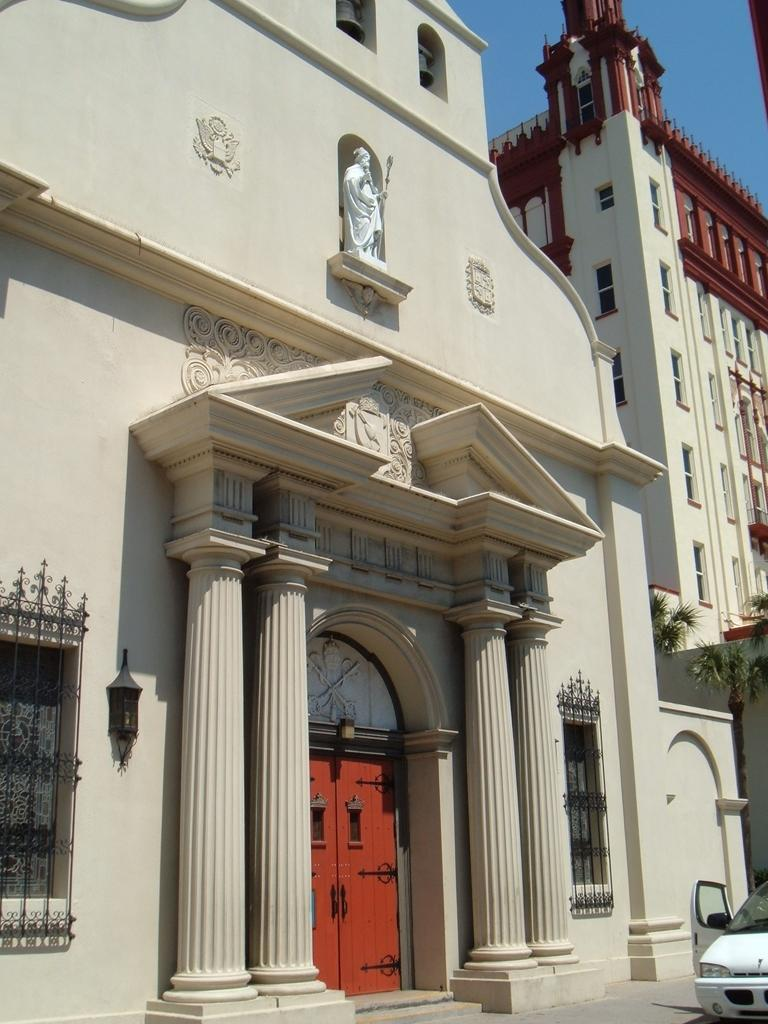What is the main subject of the image? The main subject of the image is a car on the road. What else can be seen in the image besides the car? There are buildings, trees, and the sky visible in the image. What type of quiver can be seen in the image? There is no quiver present in the image. How does the hearing system of the car work in the image? The image does not show the car's hearing system, as it is not visible or relevant to the image. 